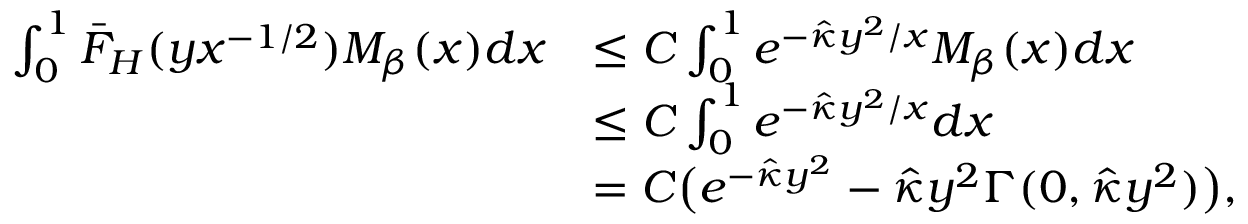Convert formula to latex. <formula><loc_0><loc_0><loc_500><loc_500>\begin{array} { r l } { \int _ { 0 } ^ { 1 } \bar { F } _ { H } ( y x ^ { - 1 / 2 } ) M _ { \beta } ( x ) d x } & { \leq C \int _ { 0 } ^ { 1 } e ^ { - \hat { \kappa } y ^ { 2 } / x } M _ { \beta } ( x ) d x } \\ & { \leq C \int _ { 0 } ^ { 1 } e ^ { - \hat { \kappa } y ^ { 2 } / x } d x } \\ & { = C \left ( e ^ { - \hat { \kappa } y ^ { 2 } } - \hat { \kappa } y ^ { 2 } \Gamma ( 0 , \hat { \kappa } y ^ { 2 } ) \right ) , } \end{array}</formula> 